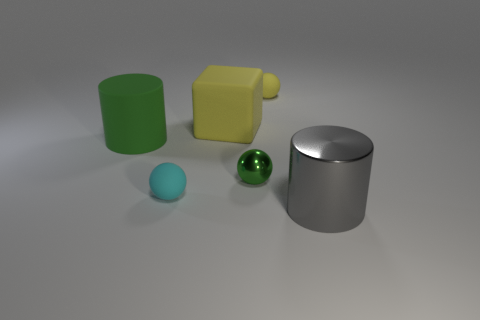There is a cube that is the same size as the metallic cylinder; what color is it?
Provide a succinct answer. Yellow. Is the material of the yellow sphere the same as the gray cylinder?
Keep it short and to the point. No. The tiny sphere that is behind the cylinder behind the cyan rubber object is made of what material?
Provide a short and direct response. Rubber. Are there more tiny cyan rubber things that are in front of the small cyan rubber sphere than big gray objects?
Offer a very short reply. No. How many other things are there of the same size as the block?
Offer a terse response. 2. Is the color of the rubber cylinder the same as the large metal cylinder?
Provide a succinct answer. No. The cylinder behind the cylinder in front of the matte object that is in front of the green shiny thing is what color?
Offer a terse response. Green. What number of tiny metal objects are in front of the matte ball that is in front of the cylinder on the left side of the yellow matte cube?
Provide a succinct answer. 0. Are there any other things that are the same color as the cube?
Ensure brevity in your answer.  Yes. Do the rubber cylinder that is left of the yellow ball and the block have the same size?
Provide a succinct answer. Yes. 